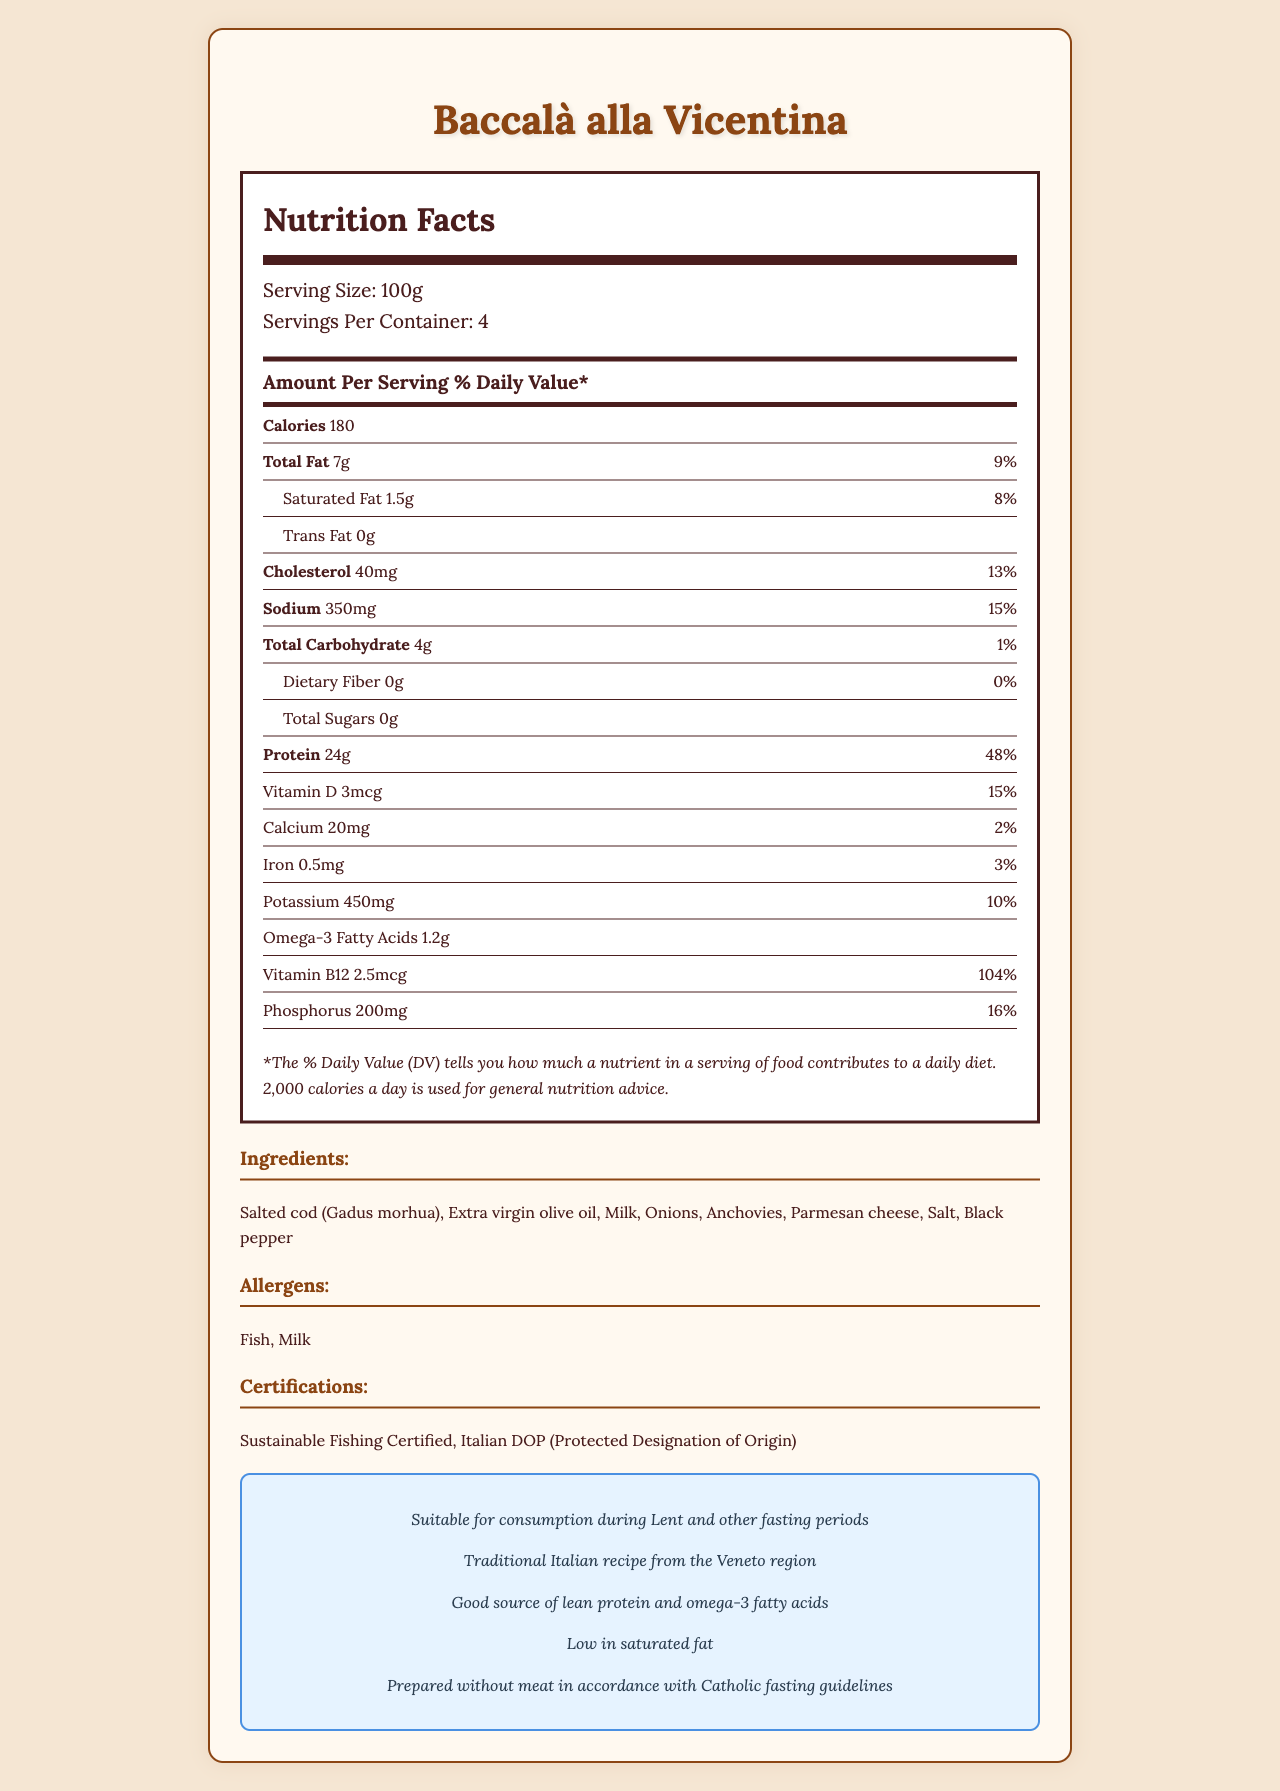what is the calories per serving? The document lists the calories per serving as 180 under the "Amount Per Serving" section.
Answer: 180 how much protein is in one serving? The nutrient section states that each serving contains 24g of protein.
Answer: 24g what is the serving size? The serving size is specified as 100g in the "Serving Size" section.
Answer: 100g what are the main allergens in this fish product? The "Allergens" section lists "Fish" and "Milk" as the main allergens.
Answer: Fish, Milk what is the amount of sodium in one serving? The document lists the sodium amount as 350mg per serving.
Answer: 350mg what percentage of daily value for vitamin B12 does one serving provide? A. 50% B. 80% C. 104% D. 130% The document shows that one serving provides 104% of the daily value for vitamin B12.
Answer: C. 104% how many servings are there per container? A. 2 B. 3 C. 4 D. 5 It is noted under the "Servings Per Container" section that there are 4 servings per container.
Answer: C. 4 is the product suitable for consumption during Lent and other fasting periods? The "Lent Info" section mentions that the product is "Suitable for consumption during Lent and other fasting periods."
Answer: Yes what type of traditional recipe is this product based on? The "Lent Info" section specifies that this product is a "Traditional Italian recipe from the Veneto region."
Answer: Traditional Italian recipe from the Veneto region how much phosphorus does one serving contain? The nutrient section lists the phosphorus content as 200mg per serving.
Answer: 200mg what is the product name? The document header indicates the product name as Baccalà alla Vicentina.
Answer: Baccalà alla Vicentina summarize the nutritional and additional details of this product. This summary provides a high-level description of the nutritional contents, allergen information, and specific dietary suitability of the product.
Answer: Baccalà alla Vicentina has a serving size of 100g with 180 calories per serving. It provides 7g of total fat, 24g of protein, and various vitamins and minerals. It contains allergens like fish and milk and is suitable for Lent, certified for sustainable fishing, and bears the Italian DOP. what is the total amount of dietary fiber per serving? The dietary fiber content is listed as 0g per serving in the nutrient section.
Answer: 0g how many total carbohydrates are in this product? The total carbohydrate content per serving is listed as 4g in the document.
Answer: 4g how much saturated fat does one serving contain? The document specifies that each serving contains 1.5g of saturated fat.
Answer: 1.5g what are the ingredients of this product? The "Ingredients" section lists all the ingredients used in this product.
Answer: Salted cod (Gadus morhua), Extra virgin olive oil, Milk, Onions, Anchovies, Parmesan cheese, Salt, Black pepper is this product prepared with meat? The "Lent Info" section specifies that the product is prepared without meat in accordance with Catholic fasting guidelines.
Answer: No what is triple the amount of Vitamin D present per serving? The document provides the amount of Vitamin D per serving (3mcg) but does not directly provide a method to compute multiples, and asking for specific multipliers is out of scope from mere visual reference.
Answer: Cannot be determined 